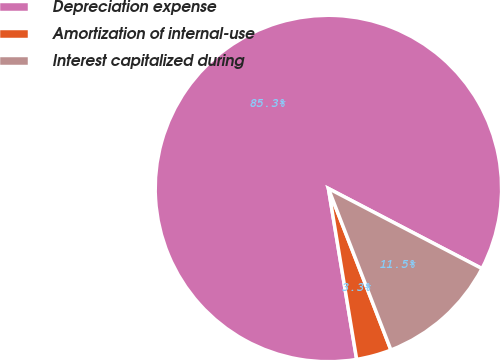<chart> <loc_0><loc_0><loc_500><loc_500><pie_chart><fcel>Depreciation expense<fcel>Amortization of internal-use<fcel>Interest capitalized during<nl><fcel>85.26%<fcel>3.27%<fcel>11.47%<nl></chart> 